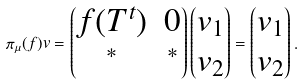<formula> <loc_0><loc_0><loc_500><loc_500>\pi _ { \mu } ( f ) v = \begin{pmatrix} f ( T ^ { t } ) & 0 \\ ^ { * } & ^ { * } \end{pmatrix} \begin{pmatrix} v _ { 1 } \\ v _ { 2 } \end{pmatrix} = \begin{pmatrix} v _ { 1 } \\ v _ { 2 } \end{pmatrix} .</formula> 